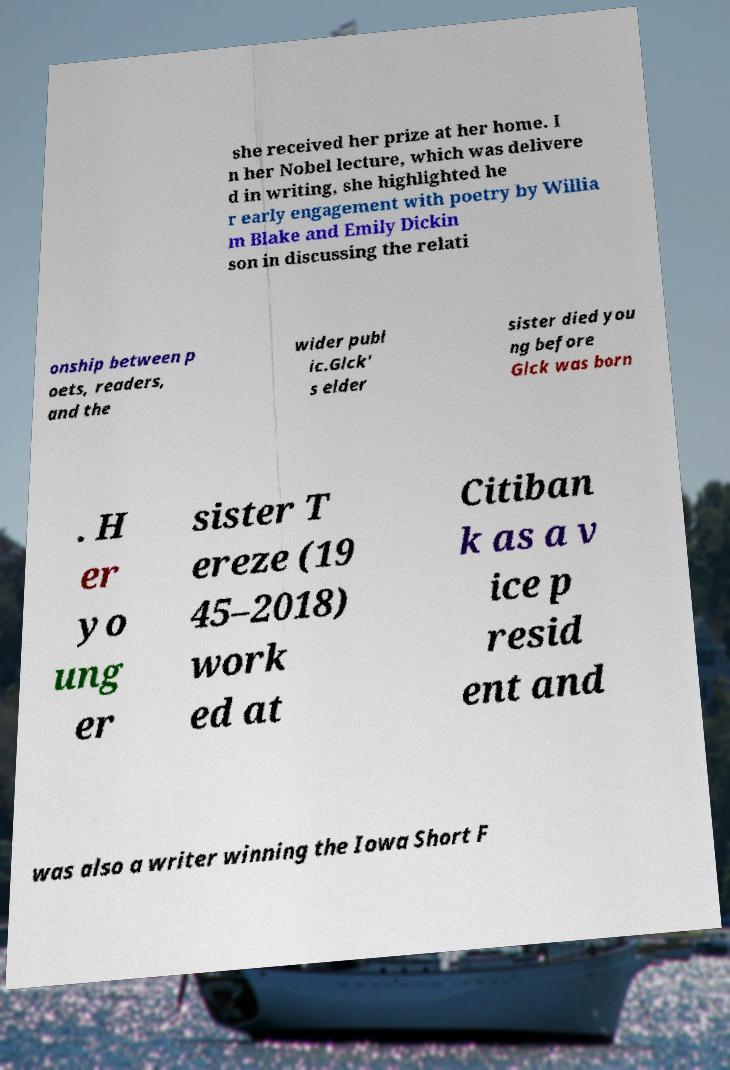There's text embedded in this image that I need extracted. Can you transcribe it verbatim? she received her prize at her home. I n her Nobel lecture, which was delivere d in writing, she highlighted he r early engagement with poetry by Willia m Blake and Emily Dickin son in discussing the relati onship between p oets, readers, and the wider publ ic.Glck' s elder sister died you ng before Glck was born . H er yo ung er sister T ereze (19 45–2018) work ed at Citiban k as a v ice p resid ent and was also a writer winning the Iowa Short F 